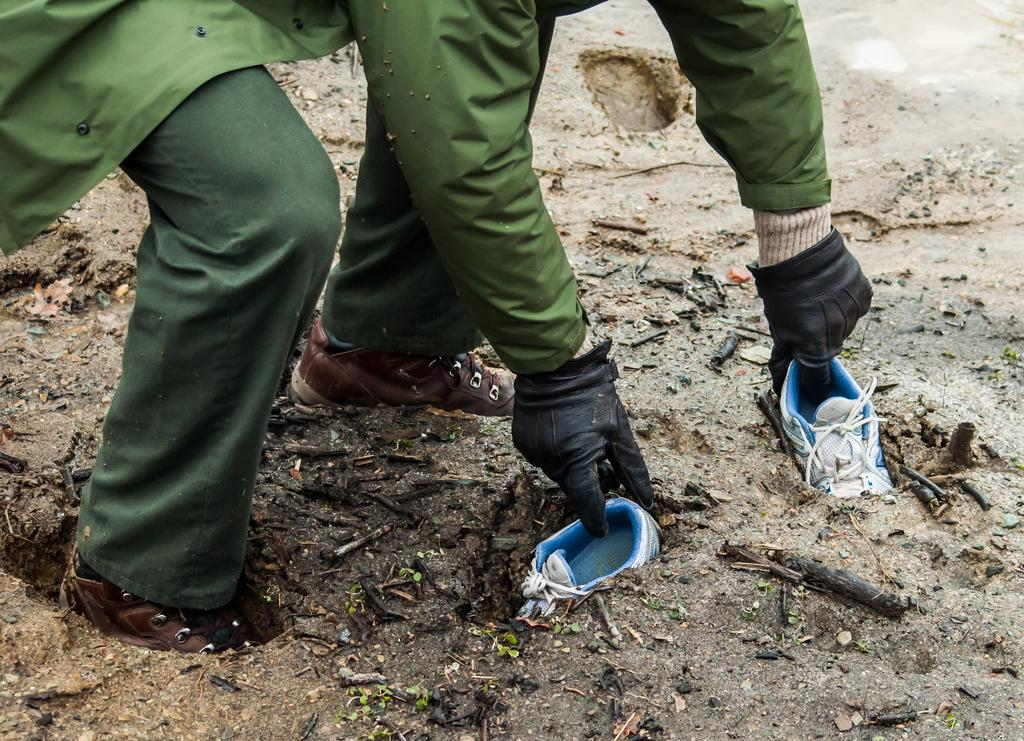What is the main subject of the image? There is a person in the image. What is the person doing in the image? The person is bending down and digging in the mud. What is the person holding in the image? The person is holding shoes. What is the person standing or sitting on in the image? The person is in the mud. What type of plate is being used to create harmony in the image? There is no plate or reference to harmony in the image; it features a person digging in the mud while holding shoes. 